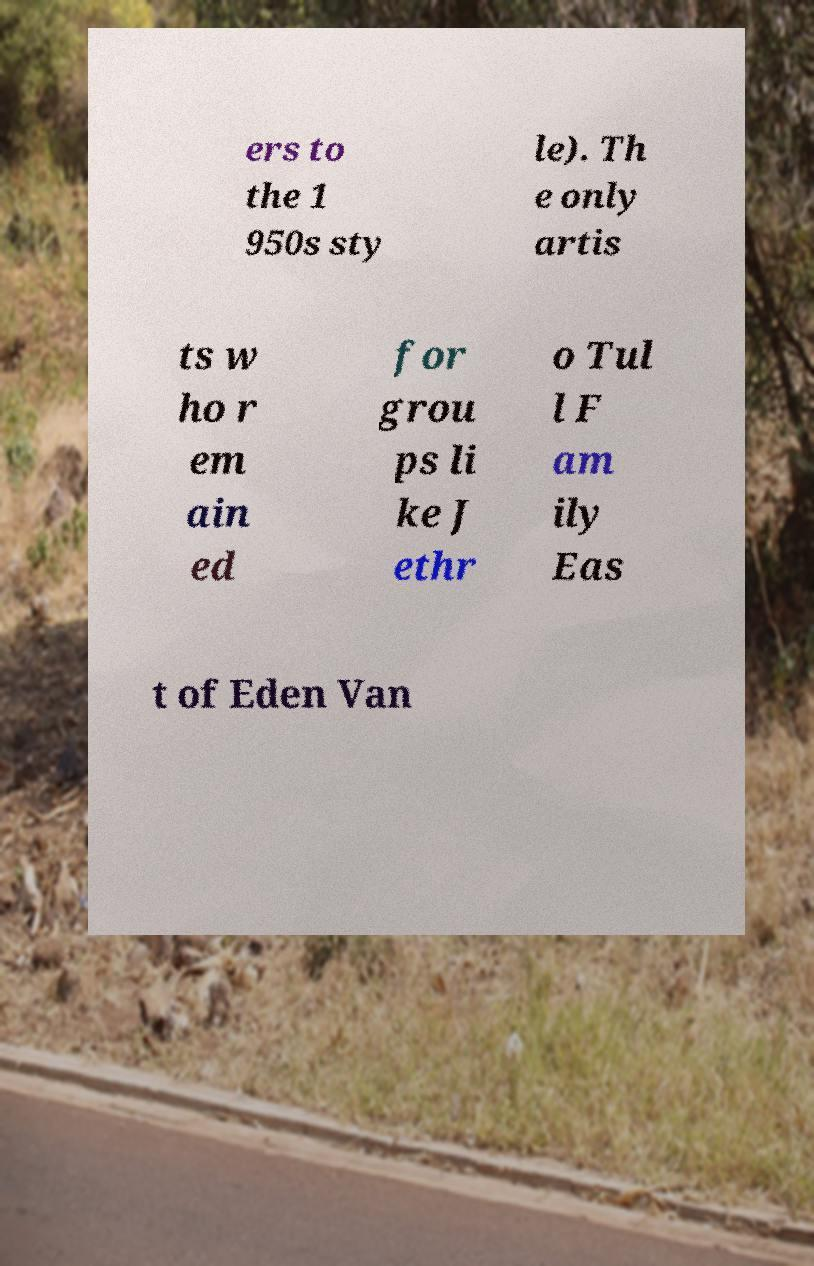Could you extract and type out the text from this image? ers to the 1 950s sty le). Th e only artis ts w ho r em ain ed for grou ps li ke J ethr o Tul l F am ily Eas t of Eden Van 